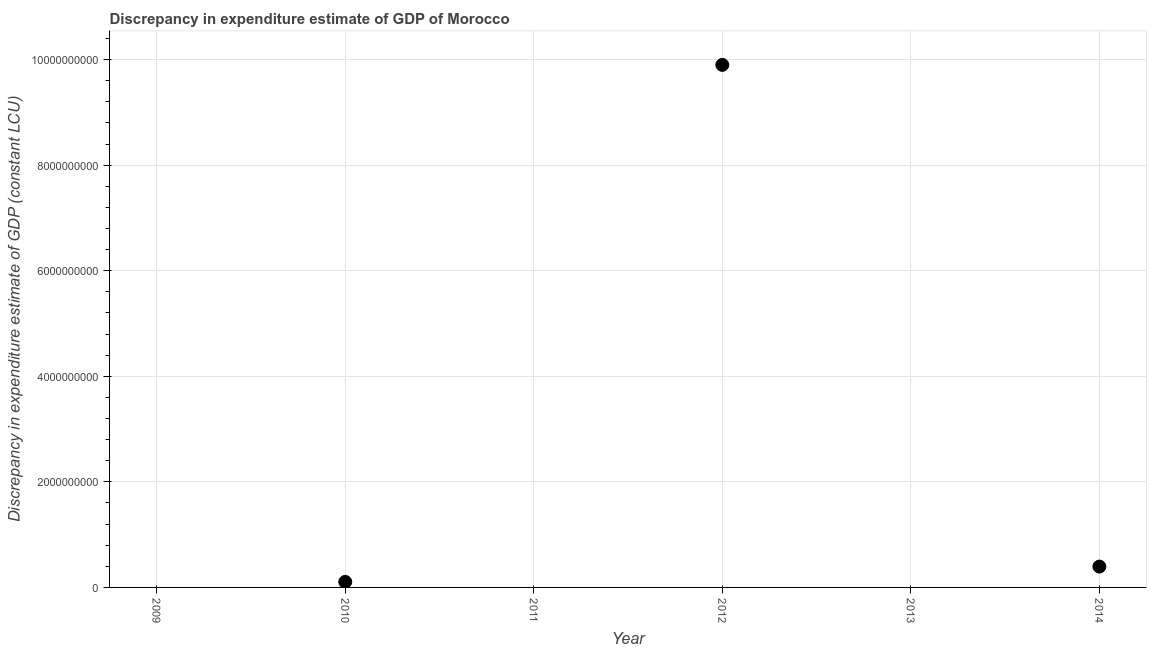What is the discrepancy in expenditure estimate of gdp in 2013?
Offer a terse response. 0. Across all years, what is the maximum discrepancy in expenditure estimate of gdp?
Ensure brevity in your answer.  9.90e+09. What is the sum of the discrepancy in expenditure estimate of gdp?
Ensure brevity in your answer.  1.04e+1. What is the difference between the discrepancy in expenditure estimate of gdp in 2012 and 2014?
Ensure brevity in your answer.  9.51e+09. What is the average discrepancy in expenditure estimate of gdp per year?
Provide a succinct answer. 1.73e+09. What is the median discrepancy in expenditure estimate of gdp?
Keep it short and to the point. 5.25e+07. In how many years, is the discrepancy in expenditure estimate of gdp greater than 5200000000 LCU?
Offer a very short reply. 1. What is the ratio of the discrepancy in expenditure estimate of gdp in 2010 to that in 2012?
Your answer should be compact. 0.01. What is the difference between the highest and the second highest discrepancy in expenditure estimate of gdp?
Your answer should be very brief. 9.51e+09. What is the difference between the highest and the lowest discrepancy in expenditure estimate of gdp?
Your answer should be very brief. 9.90e+09. In how many years, is the discrepancy in expenditure estimate of gdp greater than the average discrepancy in expenditure estimate of gdp taken over all years?
Your answer should be compact. 1. Does the discrepancy in expenditure estimate of gdp monotonically increase over the years?
Your response must be concise. No. What is the difference between two consecutive major ticks on the Y-axis?
Give a very brief answer. 2.00e+09. Does the graph contain any zero values?
Ensure brevity in your answer.  Yes. Does the graph contain grids?
Your answer should be compact. Yes. What is the title of the graph?
Keep it short and to the point. Discrepancy in expenditure estimate of GDP of Morocco. What is the label or title of the Y-axis?
Offer a very short reply. Discrepancy in expenditure estimate of GDP (constant LCU). What is the Discrepancy in expenditure estimate of GDP (constant LCU) in 2010?
Offer a terse response. 1.05e+08. What is the Discrepancy in expenditure estimate of GDP (constant LCU) in 2012?
Ensure brevity in your answer.  9.90e+09. What is the Discrepancy in expenditure estimate of GDP (constant LCU) in 2014?
Make the answer very short. 3.95e+08. What is the difference between the Discrepancy in expenditure estimate of GDP (constant LCU) in 2010 and 2012?
Your response must be concise. -9.80e+09. What is the difference between the Discrepancy in expenditure estimate of GDP (constant LCU) in 2010 and 2014?
Ensure brevity in your answer.  -2.90e+08. What is the difference between the Discrepancy in expenditure estimate of GDP (constant LCU) in 2012 and 2014?
Ensure brevity in your answer.  9.51e+09. What is the ratio of the Discrepancy in expenditure estimate of GDP (constant LCU) in 2010 to that in 2012?
Ensure brevity in your answer.  0.01. What is the ratio of the Discrepancy in expenditure estimate of GDP (constant LCU) in 2010 to that in 2014?
Provide a succinct answer. 0.27. What is the ratio of the Discrepancy in expenditure estimate of GDP (constant LCU) in 2012 to that in 2014?
Offer a terse response. 25.07. 